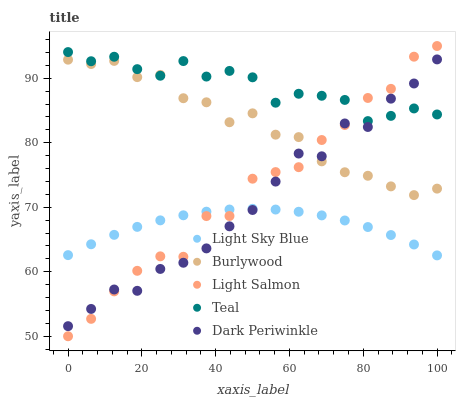Does Light Sky Blue have the minimum area under the curve?
Answer yes or no. Yes. Does Teal have the maximum area under the curve?
Answer yes or no. Yes. Does Light Salmon have the minimum area under the curve?
Answer yes or no. No. Does Light Salmon have the maximum area under the curve?
Answer yes or no. No. Is Light Sky Blue the smoothest?
Answer yes or no. Yes. Is Light Salmon the roughest?
Answer yes or no. Yes. Is Light Salmon the smoothest?
Answer yes or no. No. Is Light Sky Blue the roughest?
Answer yes or no. No. Does Light Salmon have the lowest value?
Answer yes or no. Yes. Does Light Sky Blue have the lowest value?
Answer yes or no. No. Does Light Salmon have the highest value?
Answer yes or no. Yes. Does Light Sky Blue have the highest value?
Answer yes or no. No. Is Light Sky Blue less than Teal?
Answer yes or no. Yes. Is Teal greater than Light Sky Blue?
Answer yes or no. Yes. Does Light Salmon intersect Burlywood?
Answer yes or no. Yes. Is Light Salmon less than Burlywood?
Answer yes or no. No. Is Light Salmon greater than Burlywood?
Answer yes or no. No. Does Light Sky Blue intersect Teal?
Answer yes or no. No. 